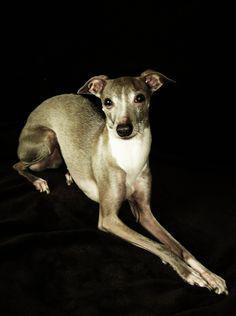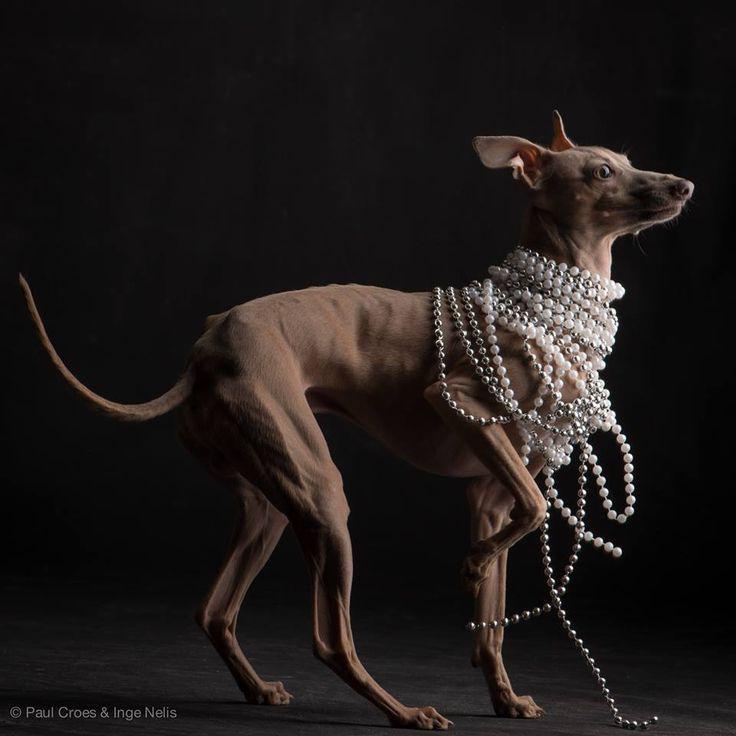The first image is the image on the left, the second image is the image on the right. Considering the images on both sides, is "The dog on the right image is facing left." valid? Answer yes or no. No. 